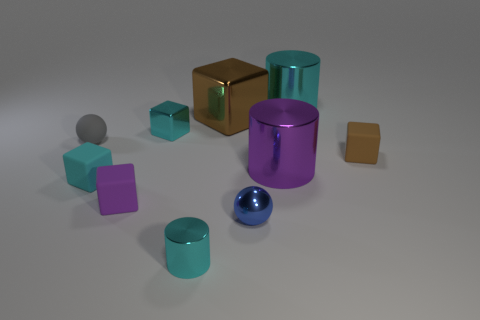There is a small metal object that is the same color as the tiny cylinder; what shape is it?
Make the answer very short. Cube. There is another tiny object that is the same shape as the purple metal object; what is its material?
Keep it short and to the point. Metal. There is a block that is made of the same material as the big brown object; what size is it?
Make the answer very short. Small. Does the brown thing to the right of the large cyan object have the same shape as the cyan object that is in front of the purple matte thing?
Your answer should be very brief. No. What is the color of the sphere that is made of the same material as the tiny purple cube?
Your response must be concise. Gray. There is a cyan shiny cylinder on the left side of the purple cylinder; does it have the same size as the brown object behind the rubber sphere?
Your answer should be very brief. No. There is a matte object that is both in front of the small gray ball and behind the purple cylinder; what is its shape?
Make the answer very short. Cube. Is there another brown block that has the same material as the tiny brown cube?
Provide a succinct answer. No. There is a thing that is the same color as the big block; what is its material?
Your answer should be very brief. Rubber. Is the cylinder behind the small matte ball made of the same material as the brown block in front of the gray rubber object?
Your response must be concise. No. 